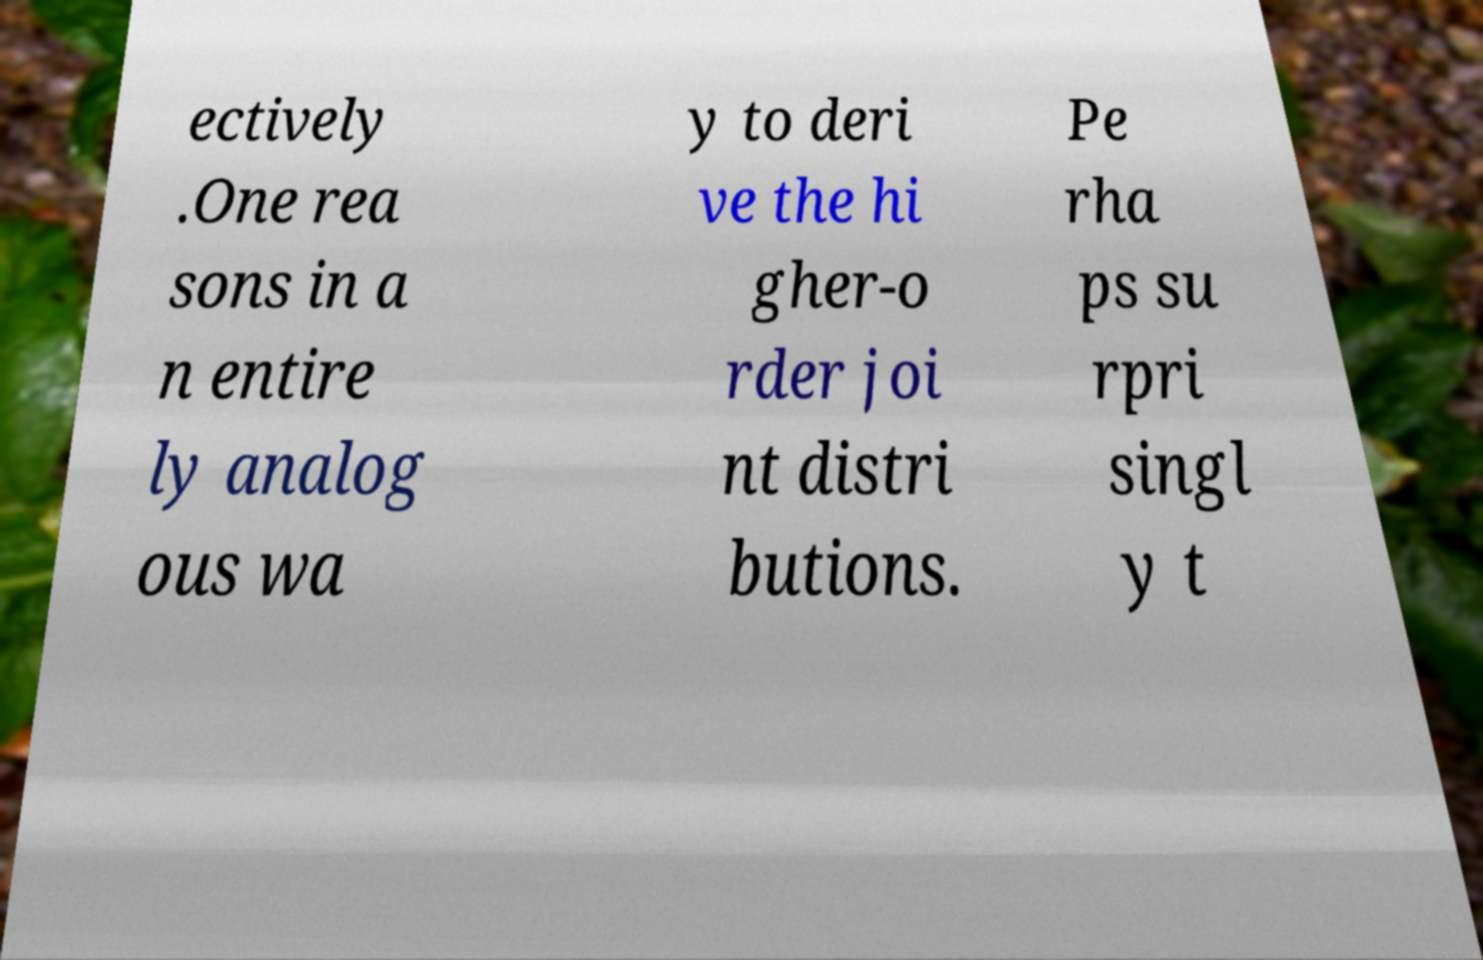Can you accurately transcribe the text from the provided image for me? ectively .One rea sons in a n entire ly analog ous wa y to deri ve the hi gher-o rder joi nt distri butions. Pe rha ps su rpri singl y t 